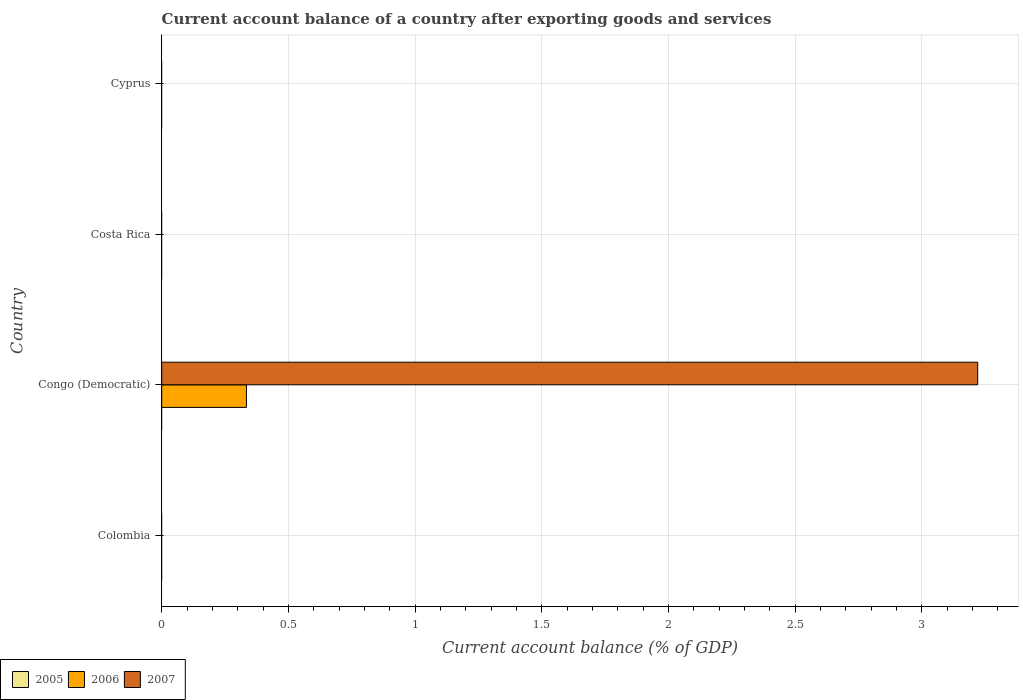Are the number of bars per tick equal to the number of legend labels?
Your answer should be compact. No. How many bars are there on the 1st tick from the top?
Give a very brief answer. 0. What is the label of the 3rd group of bars from the top?
Make the answer very short. Congo (Democratic). In how many cases, is the number of bars for a given country not equal to the number of legend labels?
Provide a short and direct response. 4. What is the account balance in 2005 in Colombia?
Give a very brief answer. 0. Across all countries, what is the maximum account balance in 2007?
Your answer should be compact. 3.22. In which country was the account balance in 2006 maximum?
Offer a very short reply. Congo (Democratic). What is the difference between the account balance in 2006 in Cyprus and the account balance in 2005 in Colombia?
Provide a short and direct response. 0. In how many countries, is the account balance in 2005 greater than 2.8 %?
Offer a very short reply. 0. What is the difference between the highest and the lowest account balance in 2006?
Keep it short and to the point. 0.33. Is it the case that in every country, the sum of the account balance in 2006 and account balance in 2005 is greater than the account balance in 2007?
Provide a short and direct response. No. How many countries are there in the graph?
Provide a succinct answer. 4. What is the difference between two consecutive major ticks on the X-axis?
Make the answer very short. 0.5. Are the values on the major ticks of X-axis written in scientific E-notation?
Your answer should be compact. No. Does the graph contain grids?
Ensure brevity in your answer.  Yes. Where does the legend appear in the graph?
Offer a very short reply. Bottom left. What is the title of the graph?
Provide a succinct answer. Current account balance of a country after exporting goods and services. What is the label or title of the X-axis?
Ensure brevity in your answer.  Current account balance (% of GDP). What is the Current account balance (% of GDP) in 2006 in Congo (Democratic)?
Provide a short and direct response. 0.33. What is the Current account balance (% of GDP) of 2007 in Congo (Democratic)?
Ensure brevity in your answer.  3.22. What is the Current account balance (% of GDP) in 2005 in Costa Rica?
Offer a terse response. 0. What is the Current account balance (% of GDP) of 2006 in Costa Rica?
Provide a succinct answer. 0. What is the Current account balance (% of GDP) of 2007 in Costa Rica?
Your answer should be compact. 0. What is the Current account balance (% of GDP) of 2005 in Cyprus?
Make the answer very short. 0. What is the Current account balance (% of GDP) in 2006 in Cyprus?
Your answer should be compact. 0. What is the Current account balance (% of GDP) in 2007 in Cyprus?
Give a very brief answer. 0. Across all countries, what is the maximum Current account balance (% of GDP) in 2006?
Ensure brevity in your answer.  0.33. Across all countries, what is the maximum Current account balance (% of GDP) of 2007?
Give a very brief answer. 3.22. What is the total Current account balance (% of GDP) of 2005 in the graph?
Your answer should be compact. 0. What is the total Current account balance (% of GDP) of 2006 in the graph?
Offer a very short reply. 0.33. What is the total Current account balance (% of GDP) of 2007 in the graph?
Offer a terse response. 3.22. What is the average Current account balance (% of GDP) of 2006 per country?
Your response must be concise. 0.08. What is the average Current account balance (% of GDP) in 2007 per country?
Provide a short and direct response. 0.81. What is the difference between the Current account balance (% of GDP) of 2006 and Current account balance (% of GDP) of 2007 in Congo (Democratic)?
Provide a short and direct response. -2.89. What is the difference between the highest and the lowest Current account balance (% of GDP) of 2006?
Offer a terse response. 0.33. What is the difference between the highest and the lowest Current account balance (% of GDP) in 2007?
Give a very brief answer. 3.22. 